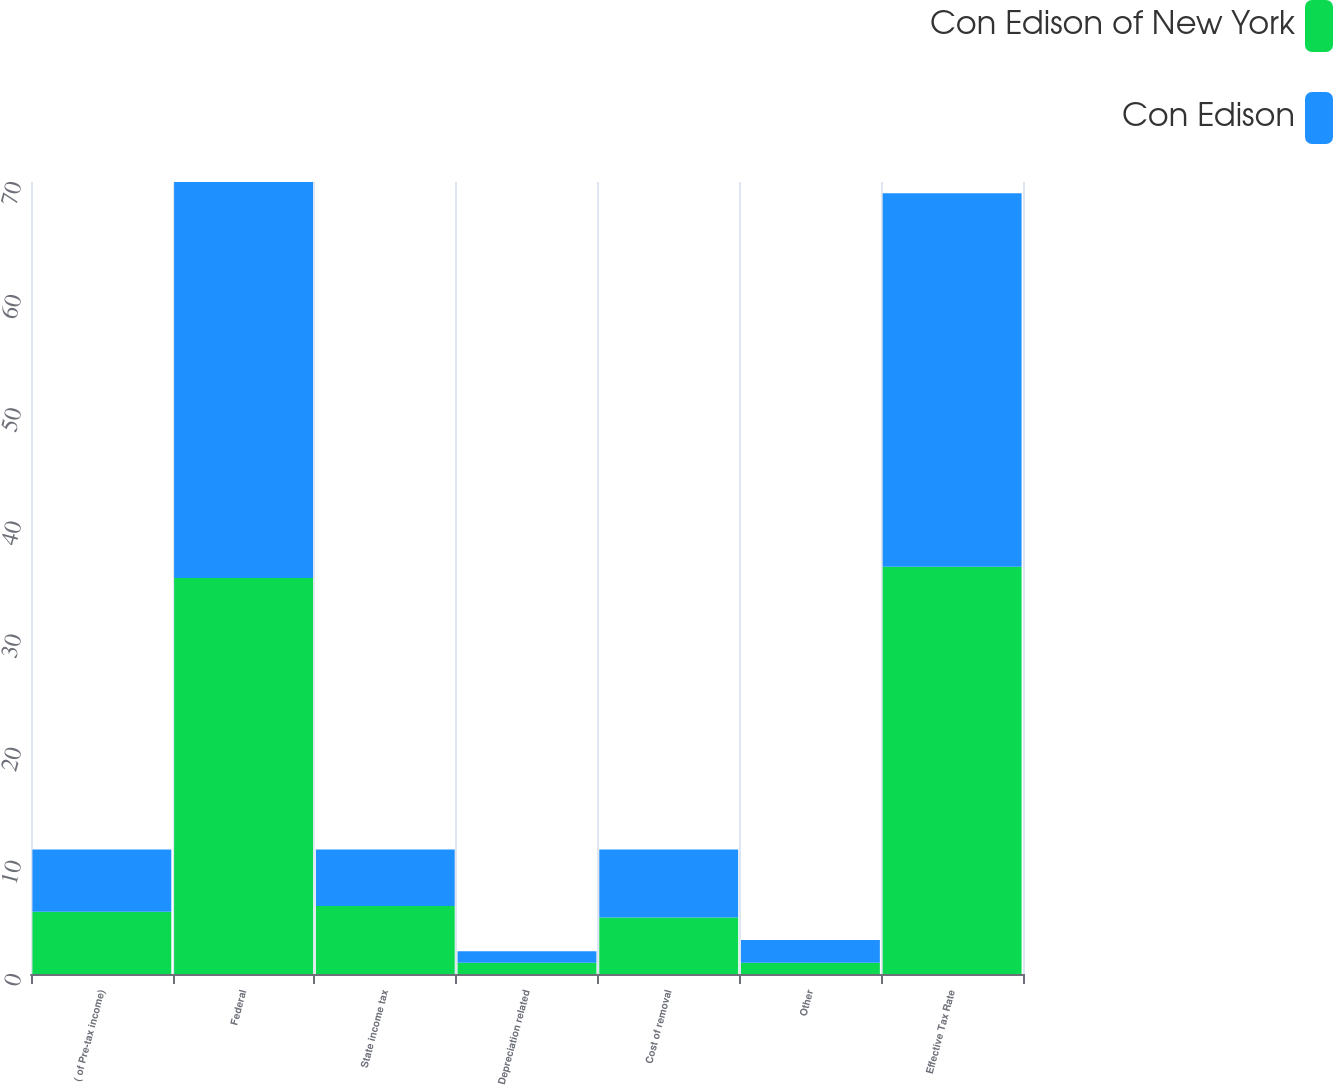Convert chart. <chart><loc_0><loc_0><loc_500><loc_500><stacked_bar_chart><ecel><fcel>( of Pre-tax income)<fcel>Federal<fcel>State income tax<fcel>Depreciation related<fcel>Cost of removal<fcel>Other<fcel>Effective Tax Rate<nl><fcel>Con Edison of New York<fcel>5.5<fcel>35<fcel>6<fcel>1<fcel>5<fcel>1<fcel>36<nl><fcel>Con Edison<fcel>5.5<fcel>35<fcel>5<fcel>1<fcel>6<fcel>2<fcel>33<nl></chart> 